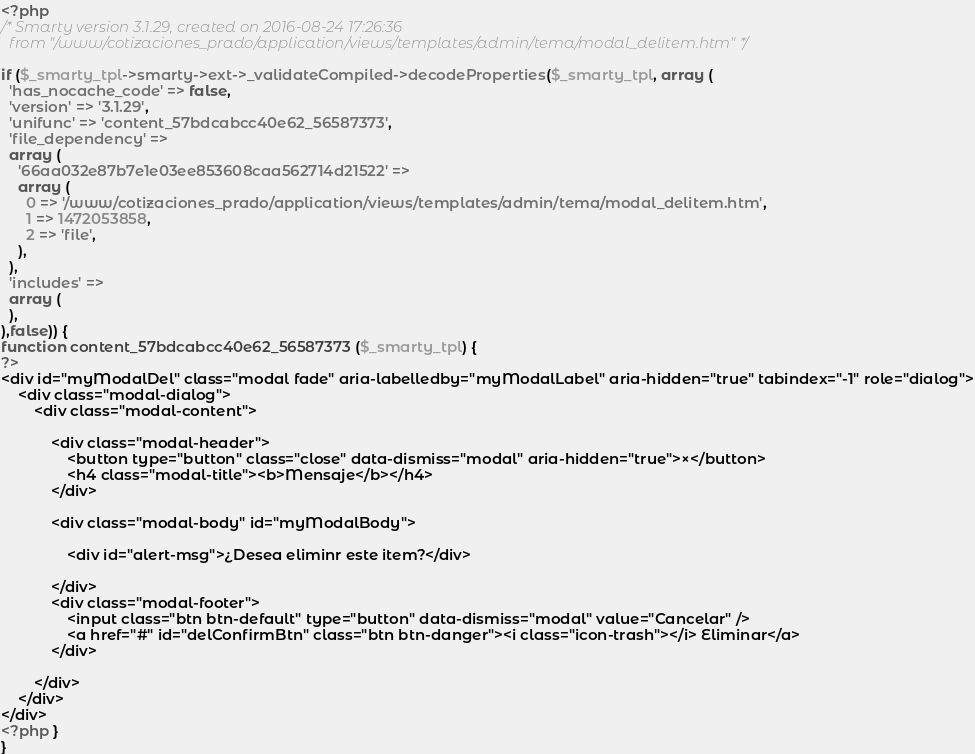<code> <loc_0><loc_0><loc_500><loc_500><_PHP_><?php
/* Smarty version 3.1.29, created on 2016-08-24 17:26:36
  from "/www/cotizaciones_prado/application/views/templates/admin/tema/modal_delitem.htm" */

if ($_smarty_tpl->smarty->ext->_validateCompiled->decodeProperties($_smarty_tpl, array (
  'has_nocache_code' => false,
  'version' => '3.1.29',
  'unifunc' => 'content_57bdcabcc40e62_56587373',
  'file_dependency' => 
  array (
    '66aa032e87b7e1e03ee853608caa562714d21522' => 
    array (
      0 => '/www/cotizaciones_prado/application/views/templates/admin/tema/modal_delitem.htm',
      1 => 1472053858,
      2 => 'file',
    ),
  ),
  'includes' => 
  array (
  ),
),false)) {
function content_57bdcabcc40e62_56587373 ($_smarty_tpl) {
?>
<div id="myModalDel" class="modal fade" aria-labelledby="myModalLabel" aria-hidden="true" tabindex="-1" role="dialog">
    <div class="modal-dialog">
        <div class="modal-content">
          
            <div class="modal-header">
                <button type="button" class="close" data-dismiss="modal" aria-hidden="true">×</button>
                <h4 class="modal-title"><b>Mensaje</b></h4>
            </div>
            
            <div class="modal-body" id="myModalBody">
                
                <div id="alert-msg">¿Desea eliminr este item?</div>

            </div>
            <div class="modal-footer">
                <input class="btn btn-default" type="button" data-dismiss="modal" value="Cancelar" />
                <a href="#" id="delConfirmBtn" class="btn btn-danger"><i class="icon-trash"></i> Eliminar</a>
            </div>

        </div>
    </div>
</div>
<?php }
}
</code> 